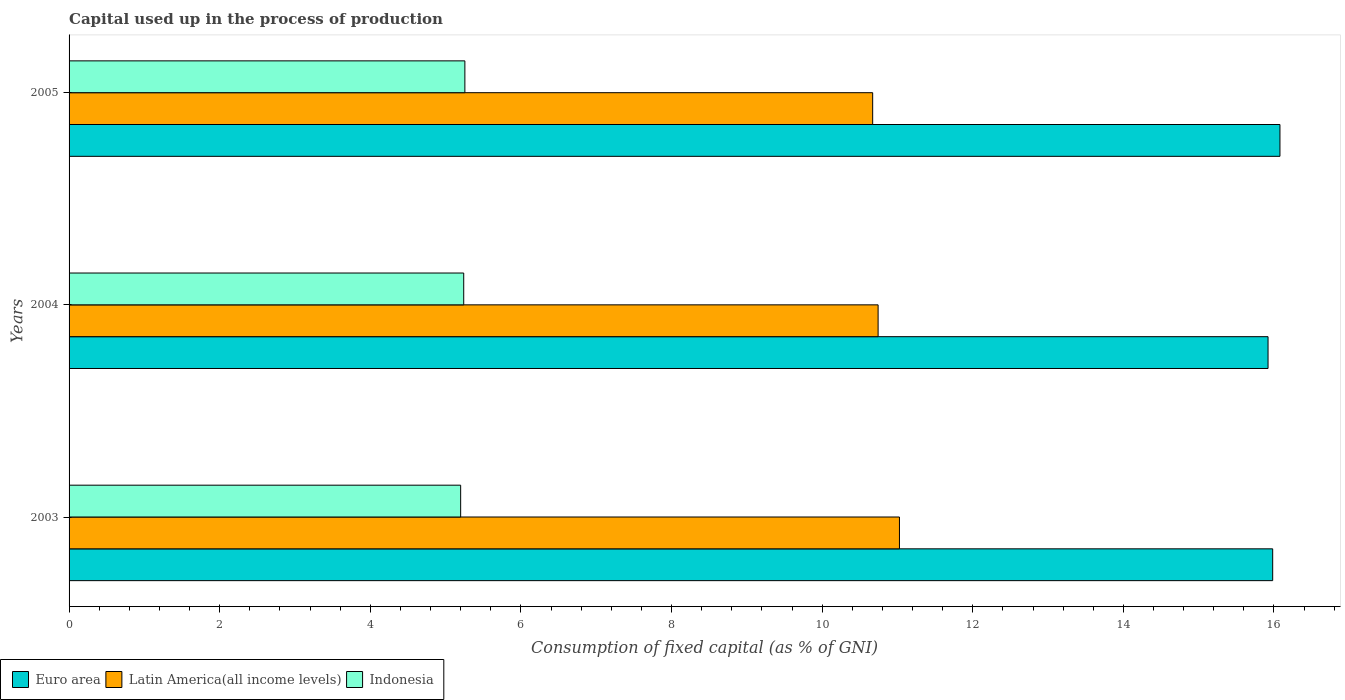How many different coloured bars are there?
Make the answer very short. 3. Are the number of bars on each tick of the Y-axis equal?
Your answer should be compact. Yes. How many bars are there on the 2nd tick from the top?
Your response must be concise. 3. How many bars are there on the 1st tick from the bottom?
Keep it short and to the point. 3. In how many cases, is the number of bars for a given year not equal to the number of legend labels?
Make the answer very short. 0. What is the capital used up in the process of production in Latin America(all income levels) in 2004?
Offer a terse response. 10.74. Across all years, what is the maximum capital used up in the process of production in Euro area?
Your response must be concise. 16.08. Across all years, what is the minimum capital used up in the process of production in Indonesia?
Keep it short and to the point. 5.2. In which year was the capital used up in the process of production in Latin America(all income levels) minimum?
Give a very brief answer. 2005. What is the total capital used up in the process of production in Indonesia in the graph?
Provide a short and direct response. 15.7. What is the difference between the capital used up in the process of production in Euro area in 2003 and that in 2004?
Make the answer very short. 0.06. What is the difference between the capital used up in the process of production in Latin America(all income levels) in 2005 and the capital used up in the process of production in Indonesia in 2003?
Offer a terse response. 5.47. What is the average capital used up in the process of production in Indonesia per year?
Your answer should be very brief. 5.23. In the year 2003, what is the difference between the capital used up in the process of production in Indonesia and capital used up in the process of production in Euro area?
Give a very brief answer. -10.78. What is the ratio of the capital used up in the process of production in Euro area in 2003 to that in 2005?
Offer a terse response. 0.99. What is the difference between the highest and the second highest capital used up in the process of production in Latin America(all income levels)?
Make the answer very short. 0.28. What is the difference between the highest and the lowest capital used up in the process of production in Latin America(all income levels)?
Provide a short and direct response. 0.36. What does the 1st bar from the top in 2003 represents?
Make the answer very short. Indonesia. Is it the case that in every year, the sum of the capital used up in the process of production in Euro area and capital used up in the process of production in Latin America(all income levels) is greater than the capital used up in the process of production in Indonesia?
Provide a succinct answer. Yes. How many bars are there?
Give a very brief answer. 9. What is the difference between two consecutive major ticks on the X-axis?
Keep it short and to the point. 2. Are the values on the major ticks of X-axis written in scientific E-notation?
Keep it short and to the point. No. Does the graph contain grids?
Give a very brief answer. No. How many legend labels are there?
Make the answer very short. 3. What is the title of the graph?
Offer a very short reply. Capital used up in the process of production. Does "Sint Maarten (Dutch part)" appear as one of the legend labels in the graph?
Your answer should be compact. No. What is the label or title of the X-axis?
Give a very brief answer. Consumption of fixed capital (as % of GNI). What is the Consumption of fixed capital (as % of GNI) of Euro area in 2003?
Offer a very short reply. 15.98. What is the Consumption of fixed capital (as % of GNI) of Latin America(all income levels) in 2003?
Keep it short and to the point. 11.03. What is the Consumption of fixed capital (as % of GNI) of Indonesia in 2003?
Your answer should be compact. 5.2. What is the Consumption of fixed capital (as % of GNI) in Euro area in 2004?
Keep it short and to the point. 15.92. What is the Consumption of fixed capital (as % of GNI) in Latin America(all income levels) in 2004?
Ensure brevity in your answer.  10.74. What is the Consumption of fixed capital (as % of GNI) of Indonesia in 2004?
Ensure brevity in your answer.  5.24. What is the Consumption of fixed capital (as % of GNI) of Euro area in 2005?
Provide a short and direct response. 16.08. What is the Consumption of fixed capital (as % of GNI) in Latin America(all income levels) in 2005?
Keep it short and to the point. 10.67. What is the Consumption of fixed capital (as % of GNI) of Indonesia in 2005?
Offer a very short reply. 5.26. Across all years, what is the maximum Consumption of fixed capital (as % of GNI) in Euro area?
Your answer should be very brief. 16.08. Across all years, what is the maximum Consumption of fixed capital (as % of GNI) in Latin America(all income levels)?
Provide a short and direct response. 11.03. Across all years, what is the maximum Consumption of fixed capital (as % of GNI) of Indonesia?
Your response must be concise. 5.26. Across all years, what is the minimum Consumption of fixed capital (as % of GNI) of Euro area?
Offer a terse response. 15.92. Across all years, what is the minimum Consumption of fixed capital (as % of GNI) in Latin America(all income levels)?
Offer a terse response. 10.67. Across all years, what is the minimum Consumption of fixed capital (as % of GNI) of Indonesia?
Your response must be concise. 5.2. What is the total Consumption of fixed capital (as % of GNI) in Euro area in the graph?
Your answer should be compact. 47.98. What is the total Consumption of fixed capital (as % of GNI) in Latin America(all income levels) in the graph?
Ensure brevity in your answer.  32.44. What is the total Consumption of fixed capital (as % of GNI) in Indonesia in the graph?
Ensure brevity in your answer.  15.7. What is the difference between the Consumption of fixed capital (as % of GNI) in Euro area in 2003 and that in 2004?
Offer a very short reply. 0.06. What is the difference between the Consumption of fixed capital (as % of GNI) of Latin America(all income levels) in 2003 and that in 2004?
Make the answer very short. 0.28. What is the difference between the Consumption of fixed capital (as % of GNI) in Indonesia in 2003 and that in 2004?
Ensure brevity in your answer.  -0.04. What is the difference between the Consumption of fixed capital (as % of GNI) of Euro area in 2003 and that in 2005?
Offer a very short reply. -0.1. What is the difference between the Consumption of fixed capital (as % of GNI) in Latin America(all income levels) in 2003 and that in 2005?
Provide a short and direct response. 0.36. What is the difference between the Consumption of fixed capital (as % of GNI) of Indonesia in 2003 and that in 2005?
Your response must be concise. -0.06. What is the difference between the Consumption of fixed capital (as % of GNI) in Euro area in 2004 and that in 2005?
Your answer should be compact. -0.16. What is the difference between the Consumption of fixed capital (as % of GNI) in Latin America(all income levels) in 2004 and that in 2005?
Ensure brevity in your answer.  0.07. What is the difference between the Consumption of fixed capital (as % of GNI) in Indonesia in 2004 and that in 2005?
Make the answer very short. -0.02. What is the difference between the Consumption of fixed capital (as % of GNI) of Euro area in 2003 and the Consumption of fixed capital (as % of GNI) of Latin America(all income levels) in 2004?
Provide a short and direct response. 5.24. What is the difference between the Consumption of fixed capital (as % of GNI) of Euro area in 2003 and the Consumption of fixed capital (as % of GNI) of Indonesia in 2004?
Make the answer very short. 10.74. What is the difference between the Consumption of fixed capital (as % of GNI) of Latin America(all income levels) in 2003 and the Consumption of fixed capital (as % of GNI) of Indonesia in 2004?
Give a very brief answer. 5.79. What is the difference between the Consumption of fixed capital (as % of GNI) of Euro area in 2003 and the Consumption of fixed capital (as % of GNI) of Latin America(all income levels) in 2005?
Offer a very short reply. 5.31. What is the difference between the Consumption of fixed capital (as % of GNI) of Euro area in 2003 and the Consumption of fixed capital (as % of GNI) of Indonesia in 2005?
Provide a succinct answer. 10.73. What is the difference between the Consumption of fixed capital (as % of GNI) in Latin America(all income levels) in 2003 and the Consumption of fixed capital (as % of GNI) in Indonesia in 2005?
Ensure brevity in your answer.  5.77. What is the difference between the Consumption of fixed capital (as % of GNI) of Euro area in 2004 and the Consumption of fixed capital (as % of GNI) of Latin America(all income levels) in 2005?
Your response must be concise. 5.25. What is the difference between the Consumption of fixed capital (as % of GNI) of Euro area in 2004 and the Consumption of fixed capital (as % of GNI) of Indonesia in 2005?
Your response must be concise. 10.67. What is the difference between the Consumption of fixed capital (as % of GNI) in Latin America(all income levels) in 2004 and the Consumption of fixed capital (as % of GNI) in Indonesia in 2005?
Keep it short and to the point. 5.49. What is the average Consumption of fixed capital (as % of GNI) of Euro area per year?
Provide a succinct answer. 15.99. What is the average Consumption of fixed capital (as % of GNI) of Latin America(all income levels) per year?
Your answer should be compact. 10.81. What is the average Consumption of fixed capital (as % of GNI) of Indonesia per year?
Give a very brief answer. 5.23. In the year 2003, what is the difference between the Consumption of fixed capital (as % of GNI) in Euro area and Consumption of fixed capital (as % of GNI) in Latin America(all income levels)?
Offer a terse response. 4.96. In the year 2003, what is the difference between the Consumption of fixed capital (as % of GNI) in Euro area and Consumption of fixed capital (as % of GNI) in Indonesia?
Ensure brevity in your answer.  10.78. In the year 2003, what is the difference between the Consumption of fixed capital (as % of GNI) in Latin America(all income levels) and Consumption of fixed capital (as % of GNI) in Indonesia?
Your answer should be compact. 5.83. In the year 2004, what is the difference between the Consumption of fixed capital (as % of GNI) in Euro area and Consumption of fixed capital (as % of GNI) in Latin America(all income levels)?
Your answer should be compact. 5.18. In the year 2004, what is the difference between the Consumption of fixed capital (as % of GNI) of Euro area and Consumption of fixed capital (as % of GNI) of Indonesia?
Ensure brevity in your answer.  10.68. In the year 2004, what is the difference between the Consumption of fixed capital (as % of GNI) in Latin America(all income levels) and Consumption of fixed capital (as % of GNI) in Indonesia?
Make the answer very short. 5.5. In the year 2005, what is the difference between the Consumption of fixed capital (as % of GNI) of Euro area and Consumption of fixed capital (as % of GNI) of Latin America(all income levels)?
Provide a short and direct response. 5.41. In the year 2005, what is the difference between the Consumption of fixed capital (as % of GNI) of Euro area and Consumption of fixed capital (as % of GNI) of Indonesia?
Your response must be concise. 10.82. In the year 2005, what is the difference between the Consumption of fixed capital (as % of GNI) of Latin America(all income levels) and Consumption of fixed capital (as % of GNI) of Indonesia?
Give a very brief answer. 5.42. What is the ratio of the Consumption of fixed capital (as % of GNI) in Euro area in 2003 to that in 2004?
Provide a succinct answer. 1. What is the ratio of the Consumption of fixed capital (as % of GNI) in Latin America(all income levels) in 2003 to that in 2004?
Your response must be concise. 1.03. What is the ratio of the Consumption of fixed capital (as % of GNI) of Indonesia in 2003 to that in 2004?
Provide a short and direct response. 0.99. What is the ratio of the Consumption of fixed capital (as % of GNI) of Euro area in 2004 to that in 2005?
Offer a terse response. 0.99. What is the ratio of the Consumption of fixed capital (as % of GNI) in Latin America(all income levels) in 2004 to that in 2005?
Make the answer very short. 1.01. What is the ratio of the Consumption of fixed capital (as % of GNI) in Indonesia in 2004 to that in 2005?
Offer a very short reply. 1. What is the difference between the highest and the second highest Consumption of fixed capital (as % of GNI) of Euro area?
Offer a terse response. 0.1. What is the difference between the highest and the second highest Consumption of fixed capital (as % of GNI) of Latin America(all income levels)?
Ensure brevity in your answer.  0.28. What is the difference between the highest and the second highest Consumption of fixed capital (as % of GNI) of Indonesia?
Provide a succinct answer. 0.02. What is the difference between the highest and the lowest Consumption of fixed capital (as % of GNI) of Euro area?
Your response must be concise. 0.16. What is the difference between the highest and the lowest Consumption of fixed capital (as % of GNI) of Latin America(all income levels)?
Make the answer very short. 0.36. What is the difference between the highest and the lowest Consumption of fixed capital (as % of GNI) of Indonesia?
Provide a succinct answer. 0.06. 